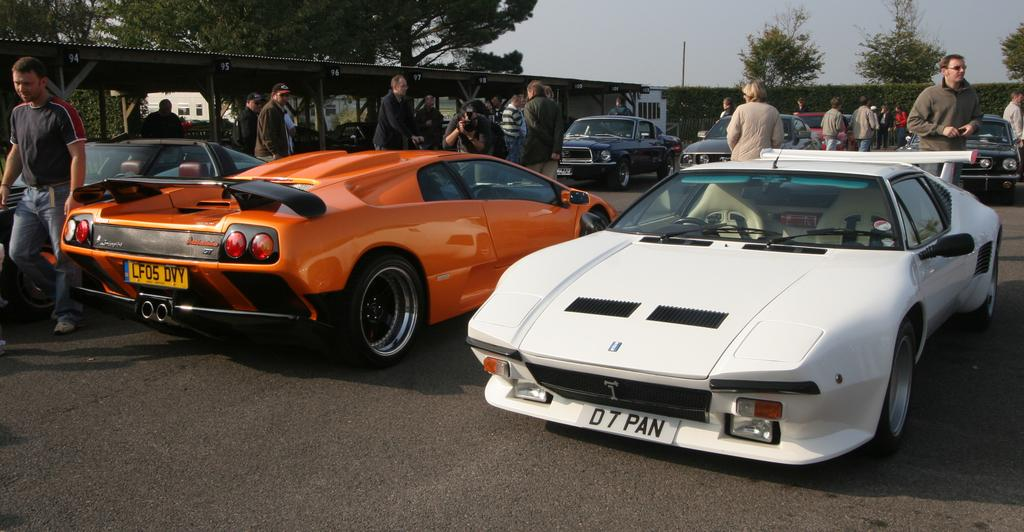What can be seen on the road in the image? There are cars on the road in the image. What are the people in the image doing? People are standing in the image. What type of vegetation is visible in the background of the image? There are plants and trees in the background of the image. What other objects can be seen in the background of the image? There is a pole and the sky is visible in the background of the image. What type of pies are being sold by the owner in the image? There is no mention of pies or an owner in the image; it features cars on the road and people standing with plants, trees, a pole, and the sky visible in the background. 